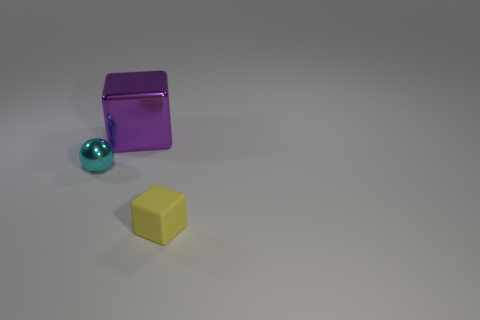How many objects are either large blue matte spheres or cubes? 2 